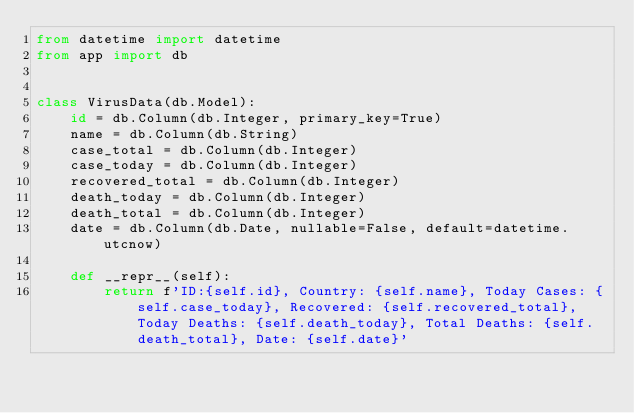<code> <loc_0><loc_0><loc_500><loc_500><_Python_>from datetime import datetime
from app import db


class VirusData(db.Model):
    id = db.Column(db.Integer, primary_key=True)
    name = db.Column(db.String)
    case_total = db.Column(db.Integer)
    case_today = db.Column(db.Integer)
    recovered_total = db.Column(db.Integer)
    death_today = db.Column(db.Integer)
    death_total = db.Column(db.Integer)
    date = db.Column(db.Date, nullable=False, default=datetime.utcnow)

    def __repr__(self):
        return f'ID:{self.id}, Country: {self.name}, Today Cases: {self.case_today}, Recovered: {self.recovered_total}, Today Deaths: {self.death_today}, Total Deaths: {self.death_total}, Date: {self.date}'
</code> 